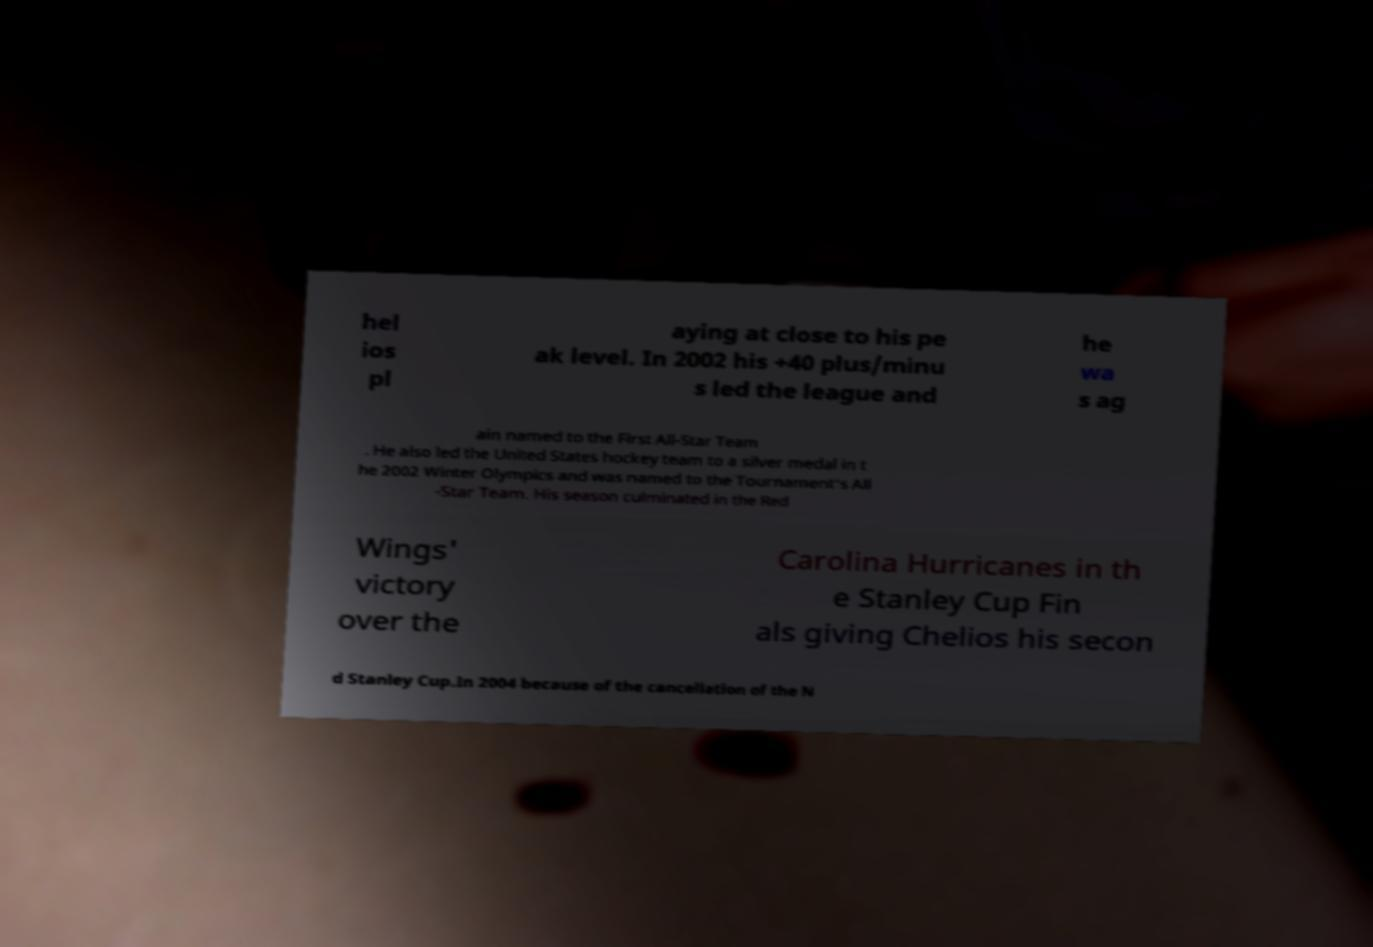Can you read and provide the text displayed in the image?This photo seems to have some interesting text. Can you extract and type it out for me? hel ios pl aying at close to his pe ak level. In 2002 his +40 plus/minu s led the league and he wa s ag ain named to the First All-Star Team . He also led the United States hockey team to a silver medal in t he 2002 Winter Olympics and was named to the Tournament's All -Star Team. His season culminated in the Red Wings' victory over the Carolina Hurricanes in th e Stanley Cup Fin als giving Chelios his secon d Stanley Cup.In 2004 because of the cancellation of the N 